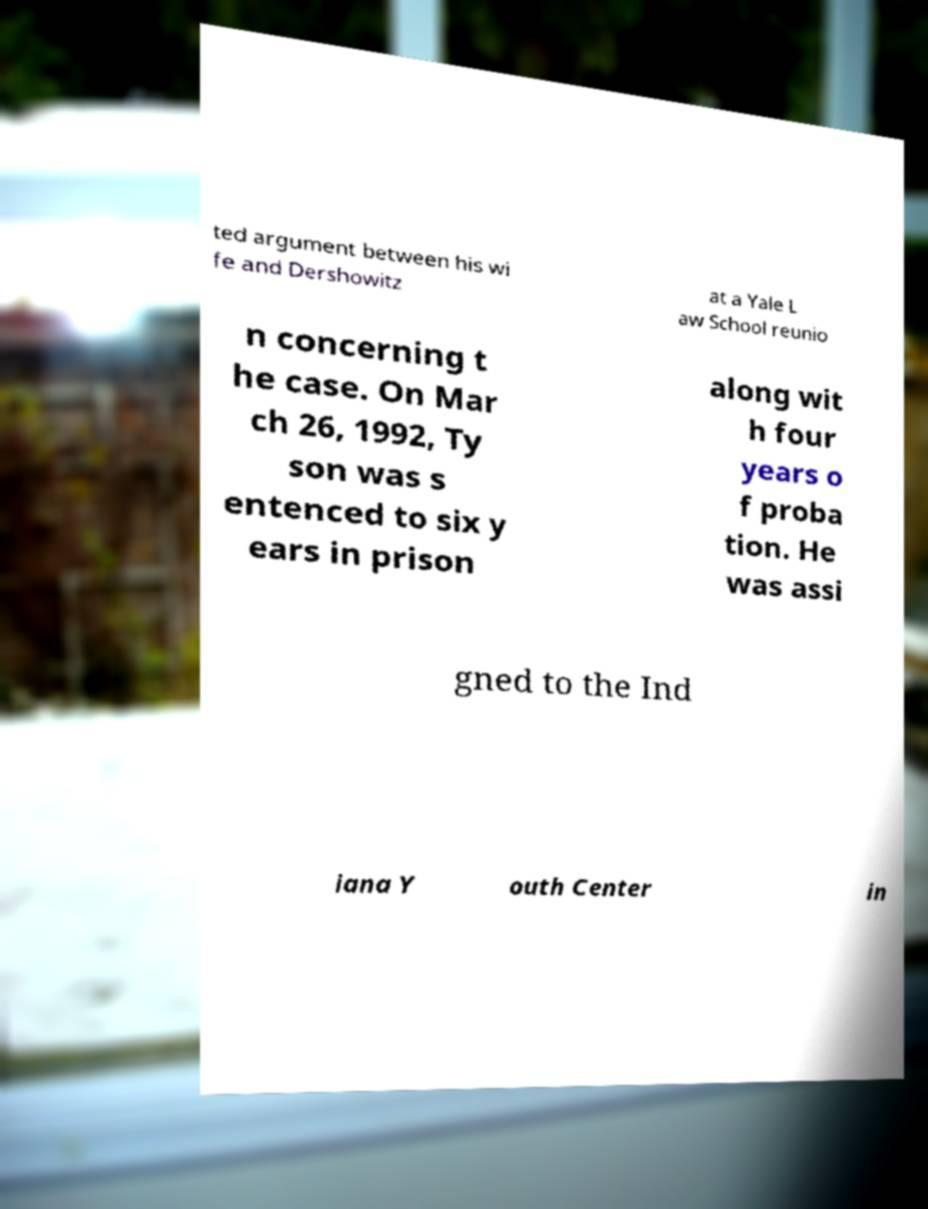I need the written content from this picture converted into text. Can you do that? ted argument between his wi fe and Dershowitz at a Yale L aw School reunio n concerning t he case. On Mar ch 26, 1992, Ty son was s entenced to six y ears in prison along wit h four years o f proba tion. He was assi gned to the Ind iana Y outh Center in 